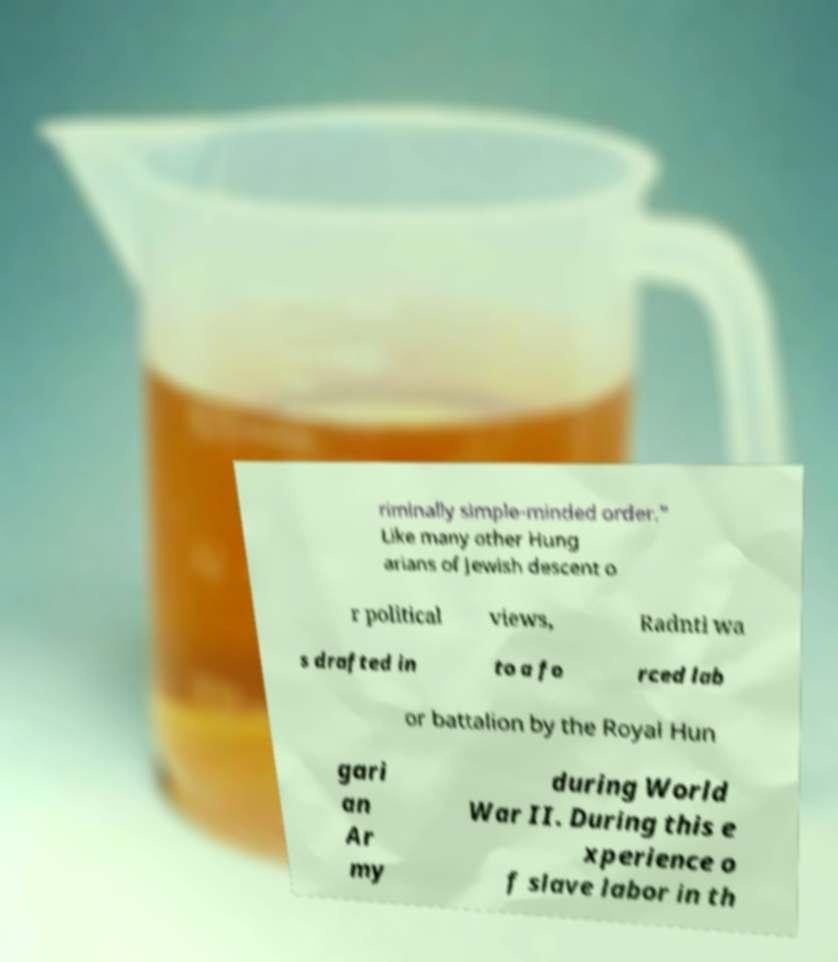Could you assist in decoding the text presented in this image and type it out clearly? riminally simple-minded order." Like many other Hung arians of Jewish descent o r political views, Radnti wa s drafted in to a fo rced lab or battalion by the Royal Hun gari an Ar my during World War II. During this e xperience o f slave labor in th 